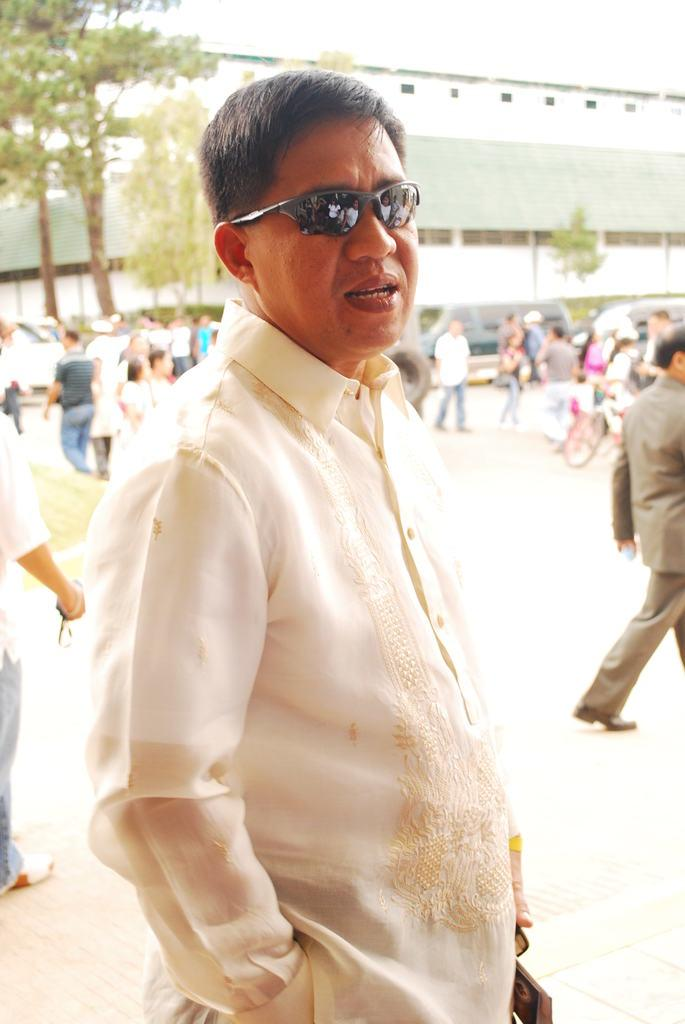How many people are in the image? There is a group of people in the image. Can you describe the man in the middle of the image? The man in the middle of the image is wearing spectacles. What can be seen in the background of the image? There are trees, buildings, and vehicles in the background of the image. What type of bell can be heard ringing in the image? There is no bell present in the image, and therefore no sound can be heard. 